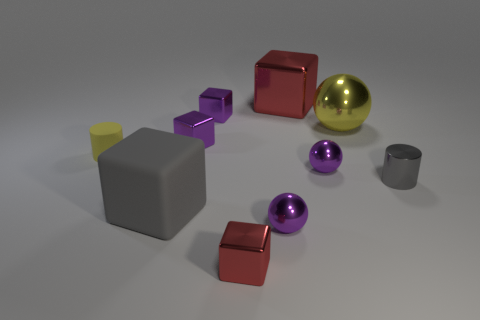What can you infer about the lighting in the scene? The shadows and subtle highlights on the objects suggest that the lighting in the scene is soft and diffused, coming from the top, as indicated by the shadows predominantly displayed underneath the objects. 